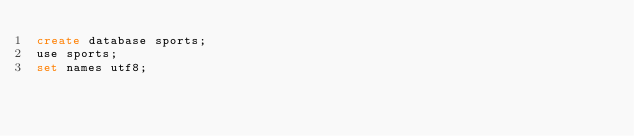Convert code to text. <code><loc_0><loc_0><loc_500><loc_500><_SQL_>create database sports;
use sports;
set names utf8;</code> 